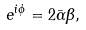Convert formula to latex. <formula><loc_0><loc_0><loc_500><loc_500>e ^ { i \phi } = 2 \bar { \alpha } \beta ,</formula> 